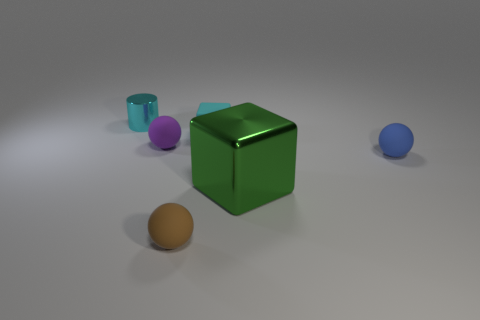Can you describe the materials the objects seem to be made of? Certainly! The large green object has a metallic sheen, suggesting it's made of metal with a reflective surface. The purple sphere looks like it could be either plastic or ceramic, indicated by its matte finish. The blue sphere also appears to have a matte finish, suggesting a similar material, while the orange sphere has a slight glossiness that could hint at a polished stone or a coated, painted surface. 